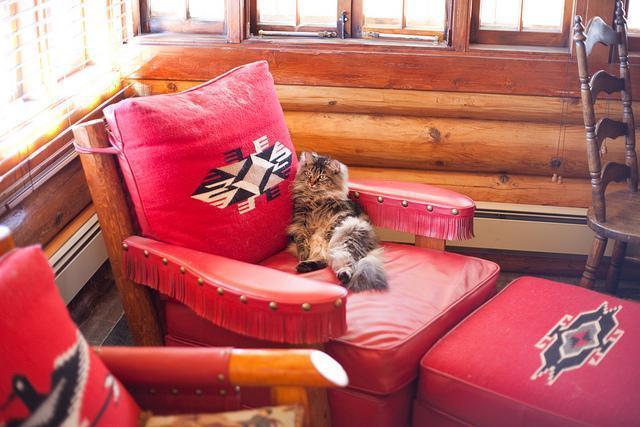What kind of walls are in this house?
From the following four choices, select the correct answer to address the question.
Options: Stone, plaster, log, brick. Log. 